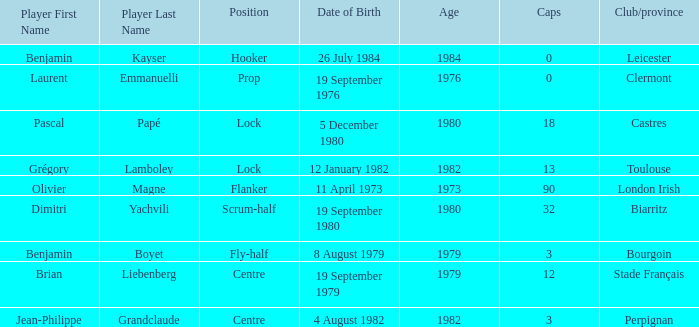Would you be able to parse every entry in this table? {'header': ['Player First Name', 'Player Last Name', 'Position', 'Date of Birth', 'Age', 'Caps', 'Club/province'], 'rows': [['Benjamin', 'Kayser', 'Hooker', '26 July 1984', '1984', '0', 'Leicester'], ['Laurent', 'Emmanuelli', 'Prop', '19 September 1976', '1976', '0', 'Clermont'], ['Pascal', 'Papé', 'Lock', '5 December 1980', '1980', '18', 'Castres'], ['Grégory', 'Lamboley', 'Lock', '12 January 1982', '1982', '13', 'Toulouse'], ['Olivier', 'Magne', 'Flanker', '11 April 1973', '1973', '90', 'London Irish'], ['Dimitri', 'Yachvili', 'Scrum-half', '19 September 1980', '1980', '32', 'Biarritz'], ['Benjamin', 'Boyet', 'Fly-half', '8 August 1979', '1979', '3', 'Bourgoin'], ['Brian', 'Liebenberg', 'Centre', '19 September 1979', '1979', '12', 'Stade Français'], ['Jean-Philippe', 'Grandclaude', 'Centre', '4 August 1982', '1982', '3', 'Perpignan']]} What is the birthday of caps of 32? 19 September 1980. 